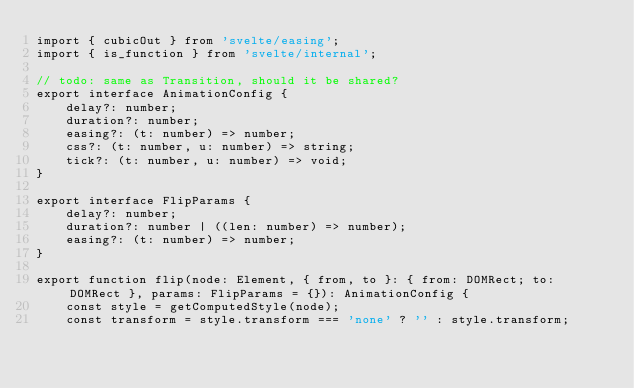<code> <loc_0><loc_0><loc_500><loc_500><_TypeScript_>import { cubicOut } from 'svelte/easing';
import { is_function } from 'svelte/internal';

// todo: same as Transition, should it be shared?
export interface AnimationConfig {
	delay?: number;
	duration?: number;
	easing?: (t: number) => number;
	css?: (t: number, u: number) => string;
	tick?: (t: number, u: number) => void;
}

export interface FlipParams {
	delay?: number;
	duration?: number | ((len: number) => number);
	easing?: (t: number) => number;
}

export function flip(node: Element, { from, to }: { from: DOMRect; to: DOMRect }, params: FlipParams = {}): AnimationConfig {
	const style = getComputedStyle(node);
	const transform = style.transform === 'none' ? '' : style.transform;
</code> 